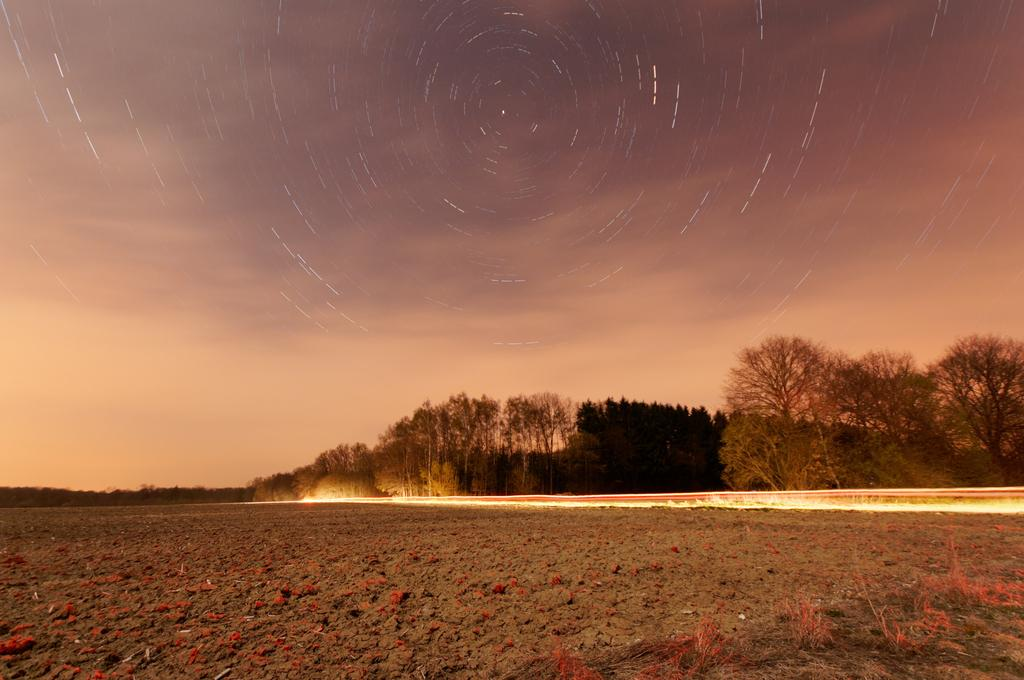What type of vegetation can be seen in the image? There are trees and plants in the image. Can you describe the sky in the image? The sky is cloudy in the image. How many horses are visible in the image? There are no horses present in the image. What type of system is being used to control the weather in the image? There is no system present in the image to control the weather, and the weather is a natural occurrence. 